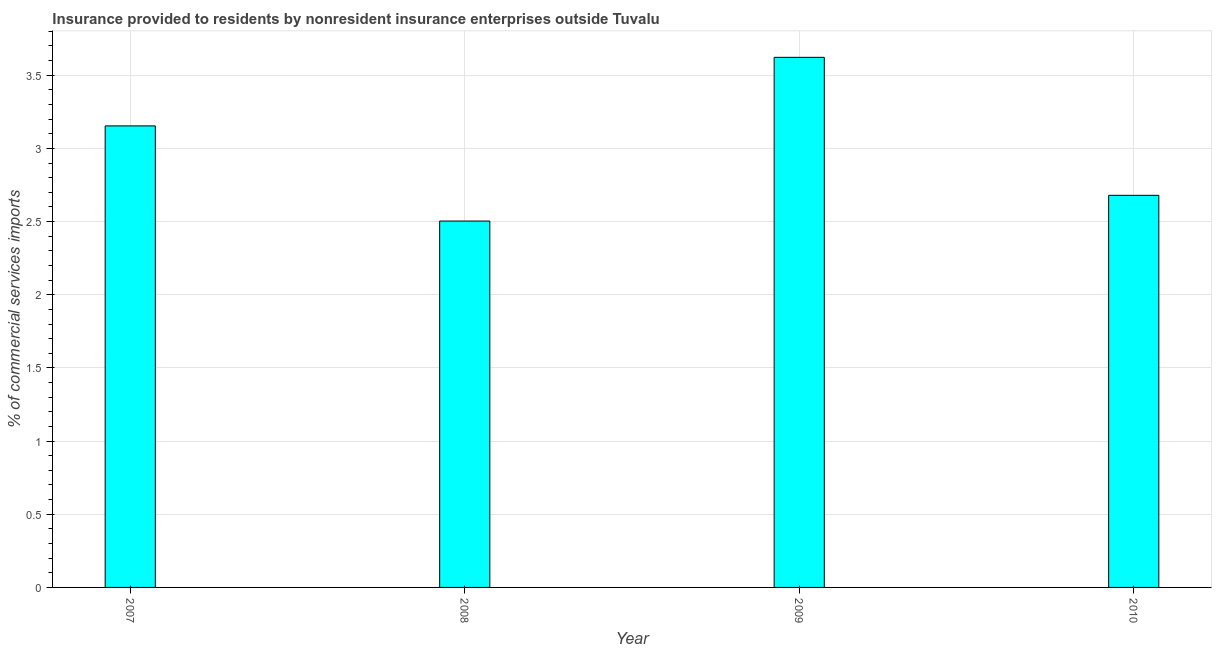Does the graph contain any zero values?
Keep it short and to the point. No. What is the title of the graph?
Ensure brevity in your answer.  Insurance provided to residents by nonresident insurance enterprises outside Tuvalu. What is the label or title of the Y-axis?
Offer a very short reply. % of commercial services imports. What is the insurance provided by non-residents in 2008?
Make the answer very short. 2.5. Across all years, what is the maximum insurance provided by non-residents?
Your answer should be compact. 3.62. Across all years, what is the minimum insurance provided by non-residents?
Provide a short and direct response. 2.5. In which year was the insurance provided by non-residents maximum?
Your answer should be compact. 2009. In which year was the insurance provided by non-residents minimum?
Your answer should be compact. 2008. What is the sum of the insurance provided by non-residents?
Provide a succinct answer. 11.96. What is the difference between the insurance provided by non-residents in 2007 and 2010?
Your response must be concise. 0.47. What is the average insurance provided by non-residents per year?
Give a very brief answer. 2.99. What is the median insurance provided by non-residents?
Provide a succinct answer. 2.92. What is the ratio of the insurance provided by non-residents in 2008 to that in 2010?
Your answer should be very brief. 0.93. Is the difference between the insurance provided by non-residents in 2009 and 2010 greater than the difference between any two years?
Ensure brevity in your answer.  No. What is the difference between the highest and the second highest insurance provided by non-residents?
Offer a very short reply. 0.47. Is the sum of the insurance provided by non-residents in 2007 and 2010 greater than the maximum insurance provided by non-residents across all years?
Offer a very short reply. Yes. What is the difference between the highest and the lowest insurance provided by non-residents?
Offer a very short reply. 1.12. How many bars are there?
Provide a short and direct response. 4. What is the difference between two consecutive major ticks on the Y-axis?
Give a very brief answer. 0.5. Are the values on the major ticks of Y-axis written in scientific E-notation?
Provide a short and direct response. No. What is the % of commercial services imports of 2007?
Your answer should be very brief. 3.15. What is the % of commercial services imports in 2008?
Provide a succinct answer. 2.5. What is the % of commercial services imports in 2009?
Offer a terse response. 3.62. What is the % of commercial services imports of 2010?
Your answer should be very brief. 2.68. What is the difference between the % of commercial services imports in 2007 and 2008?
Keep it short and to the point. 0.65. What is the difference between the % of commercial services imports in 2007 and 2009?
Make the answer very short. -0.47. What is the difference between the % of commercial services imports in 2007 and 2010?
Give a very brief answer. 0.47. What is the difference between the % of commercial services imports in 2008 and 2009?
Give a very brief answer. -1.12. What is the difference between the % of commercial services imports in 2008 and 2010?
Ensure brevity in your answer.  -0.18. What is the difference between the % of commercial services imports in 2009 and 2010?
Your response must be concise. 0.94. What is the ratio of the % of commercial services imports in 2007 to that in 2008?
Your response must be concise. 1.26. What is the ratio of the % of commercial services imports in 2007 to that in 2009?
Your answer should be compact. 0.87. What is the ratio of the % of commercial services imports in 2007 to that in 2010?
Your response must be concise. 1.18. What is the ratio of the % of commercial services imports in 2008 to that in 2009?
Give a very brief answer. 0.69. What is the ratio of the % of commercial services imports in 2008 to that in 2010?
Offer a very short reply. 0.93. What is the ratio of the % of commercial services imports in 2009 to that in 2010?
Keep it short and to the point. 1.35. 